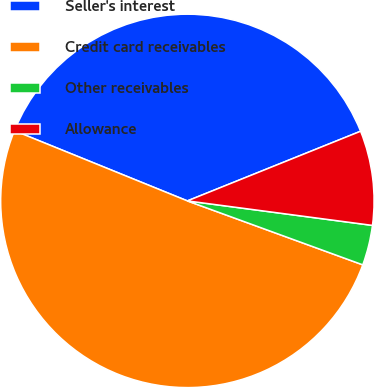Convert chart. <chart><loc_0><loc_0><loc_500><loc_500><pie_chart><fcel>Seller's interest<fcel>Credit card receivables<fcel>Other receivables<fcel>Allowance<nl><fcel>37.78%<fcel>50.57%<fcel>3.47%<fcel>8.18%<nl></chart> 